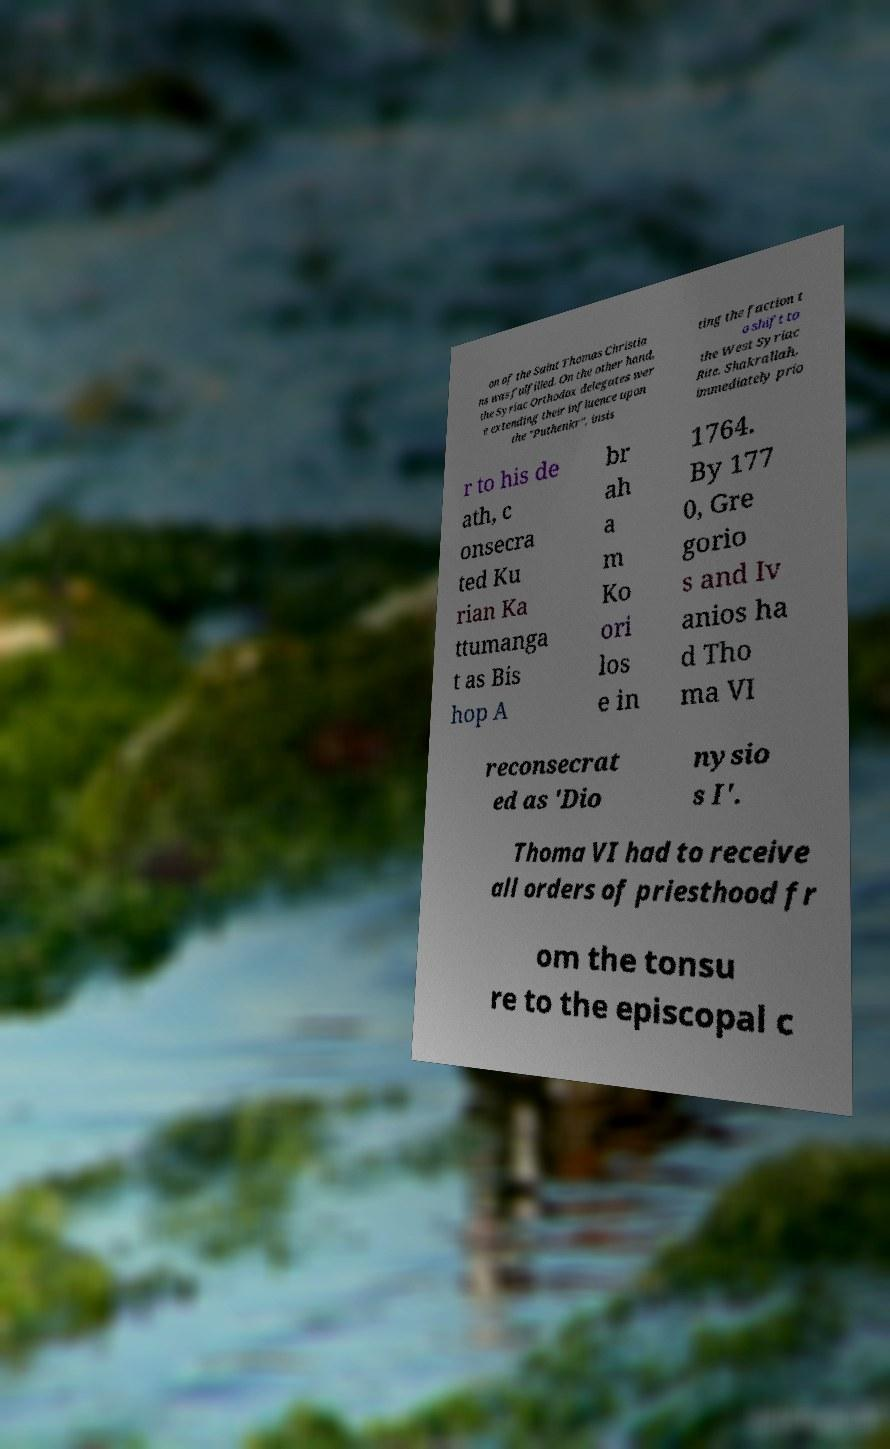Can you read and provide the text displayed in the image?This photo seems to have some interesting text. Can you extract and type it out for me? on of the Saint Thomas Christia ns was fulfilled. On the other hand, the Syriac Orthodox delegates wer e extending their influence upon the "Puthenkr", insis ting the faction t o shift to the West Syriac Rite. Shakrallah, immediately prio r to his de ath, c onsecra ted Ku rian Ka ttumanga t as Bis hop A br ah a m Ko ori los e in 1764. By 177 0, Gre gorio s and Iv anios ha d Tho ma VI reconsecrat ed as 'Dio nysio s I'. Thoma VI had to receive all orders of priesthood fr om the tonsu re to the episcopal c 